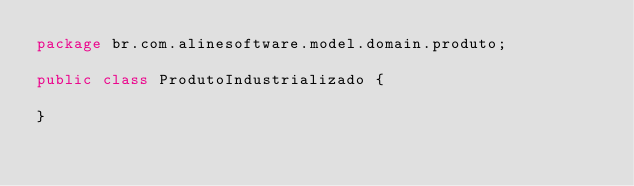<code> <loc_0><loc_0><loc_500><loc_500><_Java_>package br.com.alinesoftware.model.domain.produto;

public class ProdutoIndustrializado {

}
</code> 